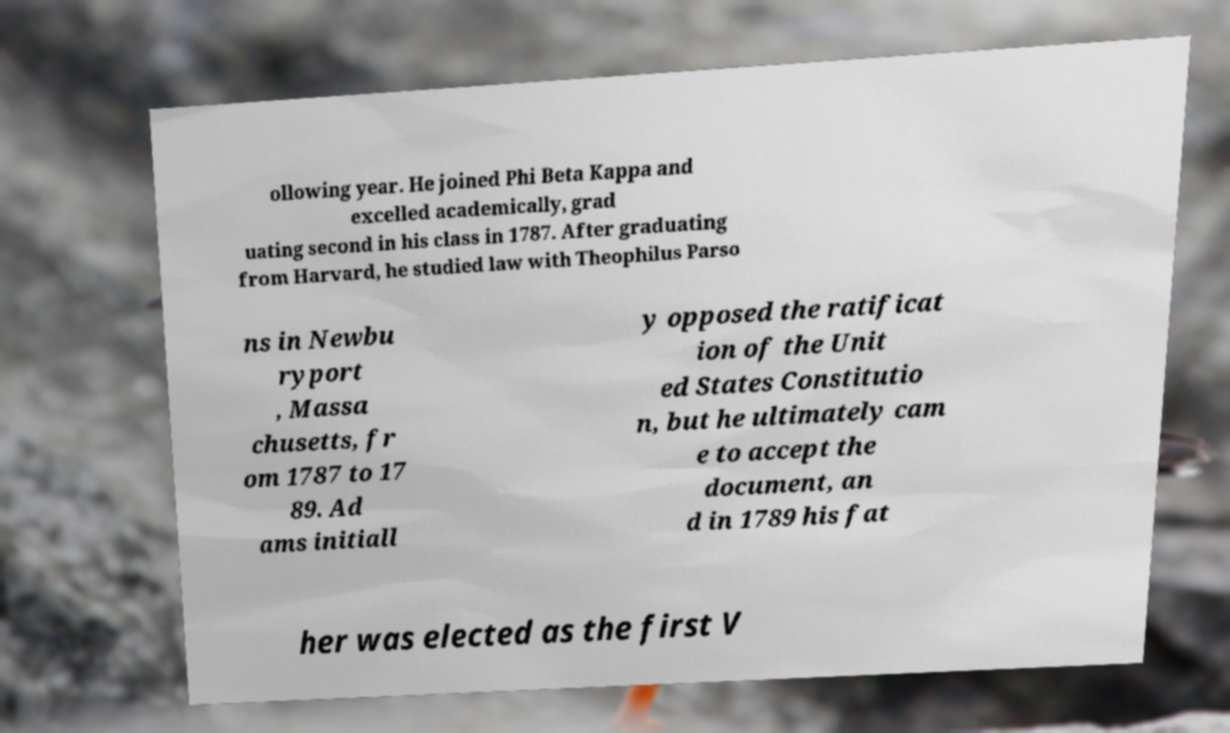Can you accurately transcribe the text from the provided image for me? ollowing year. He joined Phi Beta Kappa and excelled academically, grad uating second in his class in 1787. After graduating from Harvard, he studied law with Theophilus Parso ns in Newbu ryport , Massa chusetts, fr om 1787 to 17 89. Ad ams initiall y opposed the ratificat ion of the Unit ed States Constitutio n, but he ultimately cam e to accept the document, an d in 1789 his fat her was elected as the first V 